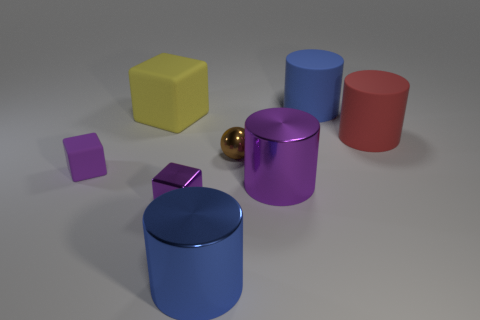What is the color of the tiny shiny sphere?
Your response must be concise. Brown. Are there any yellow rubber objects on the left side of the red thing?
Your response must be concise. Yes. Is the tiny metal cube the same color as the small rubber cube?
Keep it short and to the point. Yes. How many big metal objects have the same color as the metallic sphere?
Offer a terse response. 0. There is a blue thing that is in front of the big blue object behind the small brown sphere; what size is it?
Your answer should be very brief. Large. The yellow thing has what shape?
Keep it short and to the point. Cube. There is a small purple object on the left side of the large yellow thing; what is its material?
Make the answer very short. Rubber. The cylinder on the right side of the blue cylinder right of the small brown object that is in front of the big yellow thing is what color?
Offer a very short reply. Red. There is a block that is the same size as the blue matte thing; what is its color?
Keep it short and to the point. Yellow. How many shiny things are yellow objects or large things?
Offer a terse response. 2. 